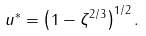Convert formula to latex. <formula><loc_0><loc_0><loc_500><loc_500>u ^ { \ast } = \left ( 1 - \zeta ^ { 2 / 3 } \right ) ^ { 1 / 2 } .</formula> 